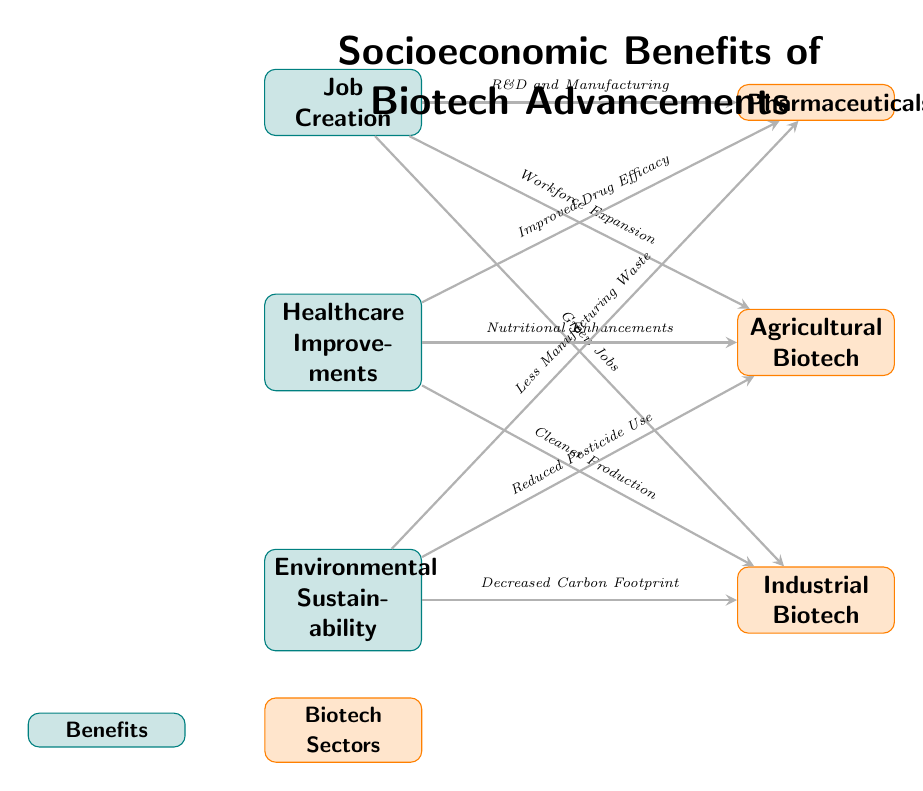What are the three main socioeconomic benefits depicted in the diagram? The diagram lists three benefits: Job Creation, Healthcare Improvements, and Environmental Sustainability. These benefits are clearly labeled as nodes in the diagram.
Answer: Job Creation, Healthcare Improvements, Environmental Sustainability How many biotech sectors are represented in the diagram? The diagram shows three biotech sectors: Pharmaceuticals, Agricultural Biotech, and Industrial Biotech. By counting the sector nodes on the right side, we find that there are three sectors.
Answer: 3 What connection links job creation to agricultural biotech? The connection between job creation and agricultural biotech is labeled as "Workforce Expansion." This is indicated by the arrow connecting the two nodes with this specific label.
Answer: Workforce Expansion Which biotech sector is linked to healthcare improvements by improved drug efficacy? The Pharmaceuticals sector is connected to healthcare improvements through "Improved Drug Efficacy." This connection is shown by an arrow leading from the healthcare improvements node to the pharmaceuticals sector node.
Answer: Pharmaceuticals Which environmental benefit is associated with reduced pesticide use? The environmental benefit linked to reduced pesticide use is Agricultural Biotech. The connection is explicitly illustrated by an arrow pointing from the environmental sustainability node to the agricultural biotech sector node, labeled as such.
Answer: Agricultural Biotech What benefit is related to cleaner production in industrial biotech? The benefit related to cleaner production in industrial biotech is Healthcare Improvements. This is shown by the arrow connecting the healthcare improvements node to the industrial biotech sector node, with the relationship labeled accordingly.
Answer: Healthcare Improvements 